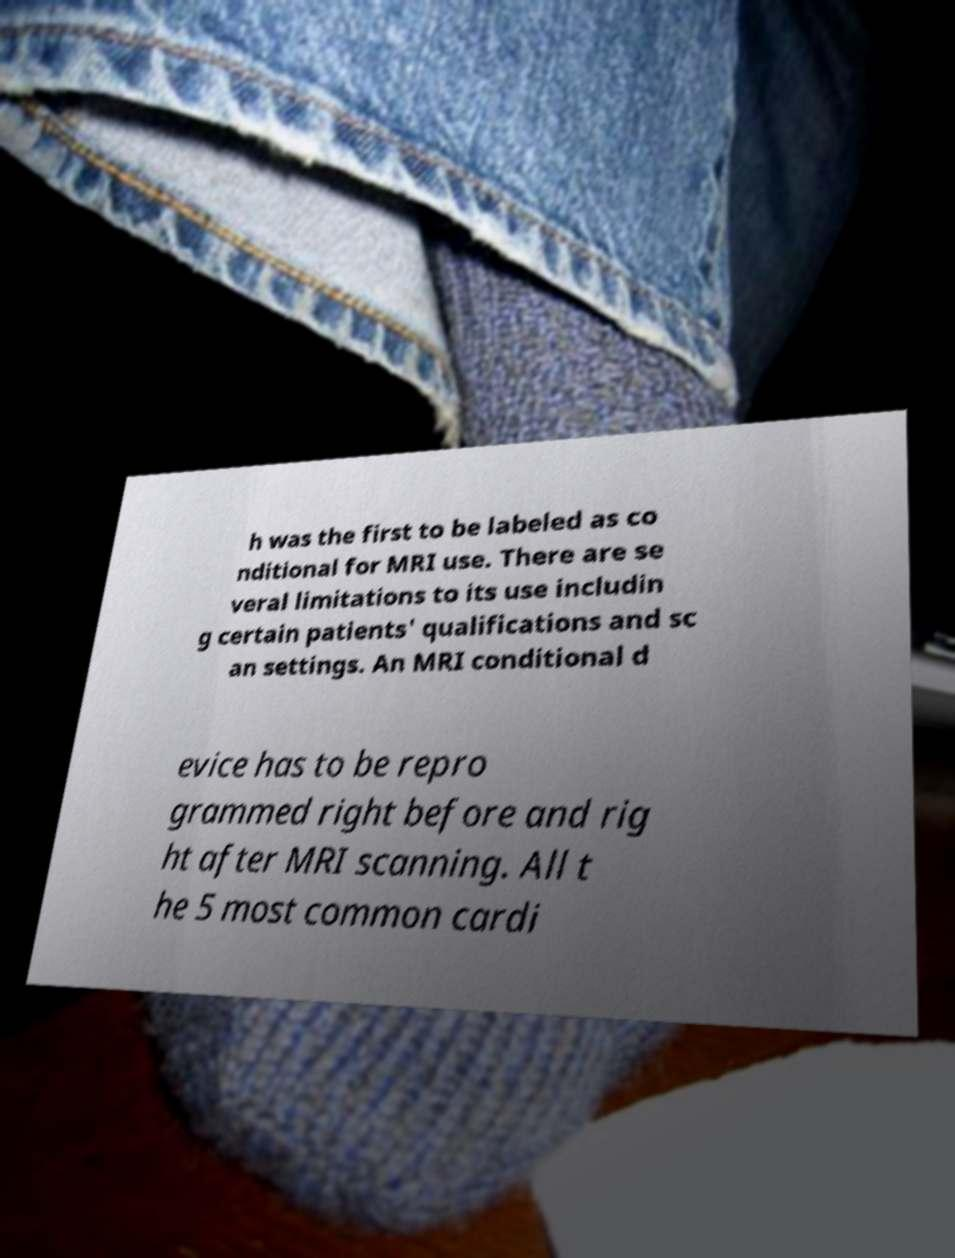There's text embedded in this image that I need extracted. Can you transcribe it verbatim? h was the first to be labeled as co nditional for MRI use. There are se veral limitations to its use includin g certain patients' qualifications and sc an settings. An MRI conditional d evice has to be repro grammed right before and rig ht after MRI scanning. All t he 5 most common cardi 